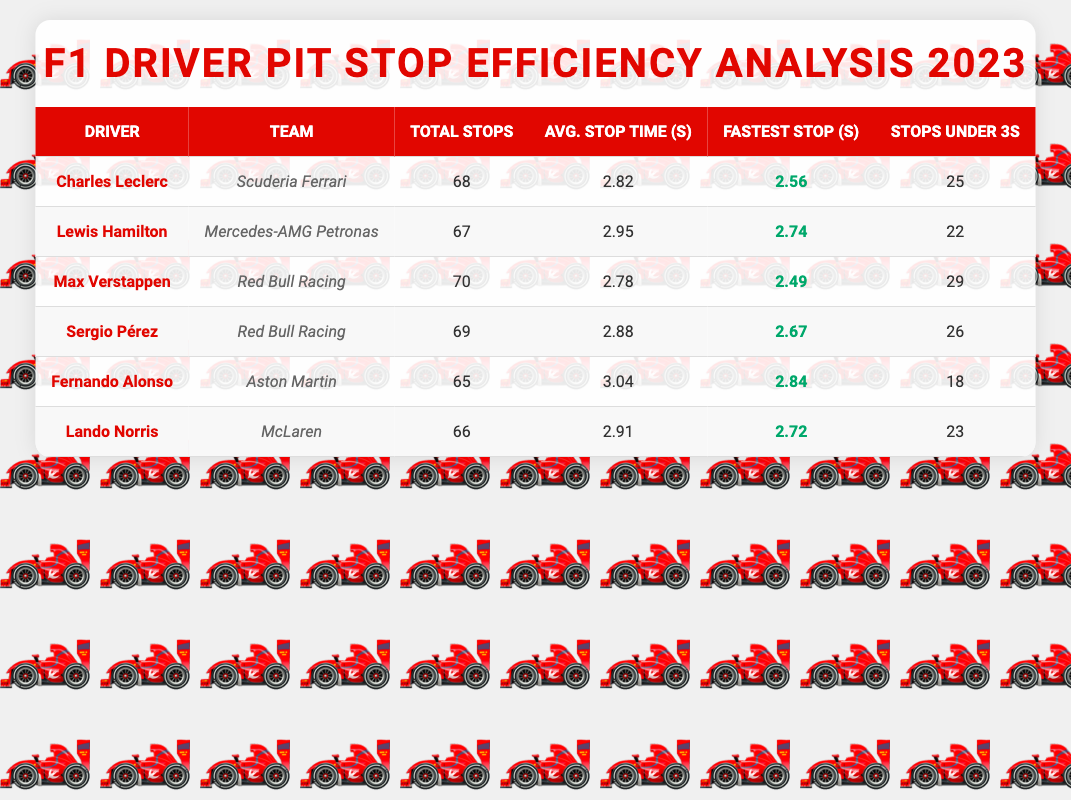What is the fastest pit stop time recorded among the drivers? From the table, the fastest stop times are listed: Charles Leclerc has 2.56 seconds, Lewis Hamilton has 2.74 seconds, Max Verstappen has 2.49 seconds, Sergio Pérez has 2.67 seconds, Fernando Alonso has 2.84 seconds, and Lando Norris has 2.72 seconds. Comparing these times, Max Verstappen's 2.49 seconds is the lowest.
Answer: 2.49 seconds How many stops did Fernando Alonso have during the season? By reviewing the table, we can see that Fernando Alonso's total stops are specifically mentioned in the data, which is 65.
Answer: 65 Which driver had the highest average pit stop time? The average stop times are listed for each driver: Charles Leclerc has 2.82 seconds, Lewis Hamilton has 2.95 seconds, Max Verstappen has 2.78 seconds, Sergio Pérez has 2.88 seconds, Fernando Alonso has 3.04 seconds, and Lando Norris has 2.91 seconds. The highest average stop time is from Fernando Alonso at 3.04 seconds.
Answer: 3.04 seconds True or False: Max Verstappen recorded more than 25 stops under 3 seconds. The data indicates that Max Verstappen had 29 stops under 3 seconds, which is indeed more than 25. Therefore, this statement is true.
Answer: True What is the average number of stops under 3 seconds by the drivers? We calculate the average by summing the stops under 3 seconds: (25 + 22 + 29 + 26 + 18 + 23) = 143. There are 6 drivers, so the average is 143/6 = 23.83.
Answer: 23.83 Which team had the most total pit stops? Reviewing the total stops, Scuderia Ferrari had 68 (Charles Leclerc), Red Bull Racing had 70 (Max Verstappen, Sergio Pérez), Mercedes-AMG Petronas had 67 (Lewis Hamilton), Aston Martin had 65 (Fernando Alonso), and McLaren had 66 (Lando Norris). The team with the most total stops is Red Bull Racing with 70 stops.
Answer: Red Bull Racing What is the difference in the average pit stop time between Lewis Hamilton and Charles Leclerc? Lewis Hamilton's average stop time is 2.95 seconds and Charles Leclerc's is 2.82 seconds. To find the difference, we subtract: 2.95 - 2.82 = 0.13 seconds.
Answer: 0.13 seconds How many drivers had an average pit stop time below 3 seconds? Evaluating the average pit stop times, we see that Charles Leclerc (2.82), Max Verstappen (2.78), and Sergio Pérez (2.88) are below 3 seconds. That's a total of 3 drivers who meet this criterion.
Answer: 3 drivers Did Lando Norris have a faster average stop time than Fernando Alonso? Lando Norris's average stop time is 2.91 seconds and Fernando Alonso's is 3.04 seconds. Since 2.91 is less than 3.04, this means Lando Norris did indeed have a faster average stop time.
Answer: Yes 